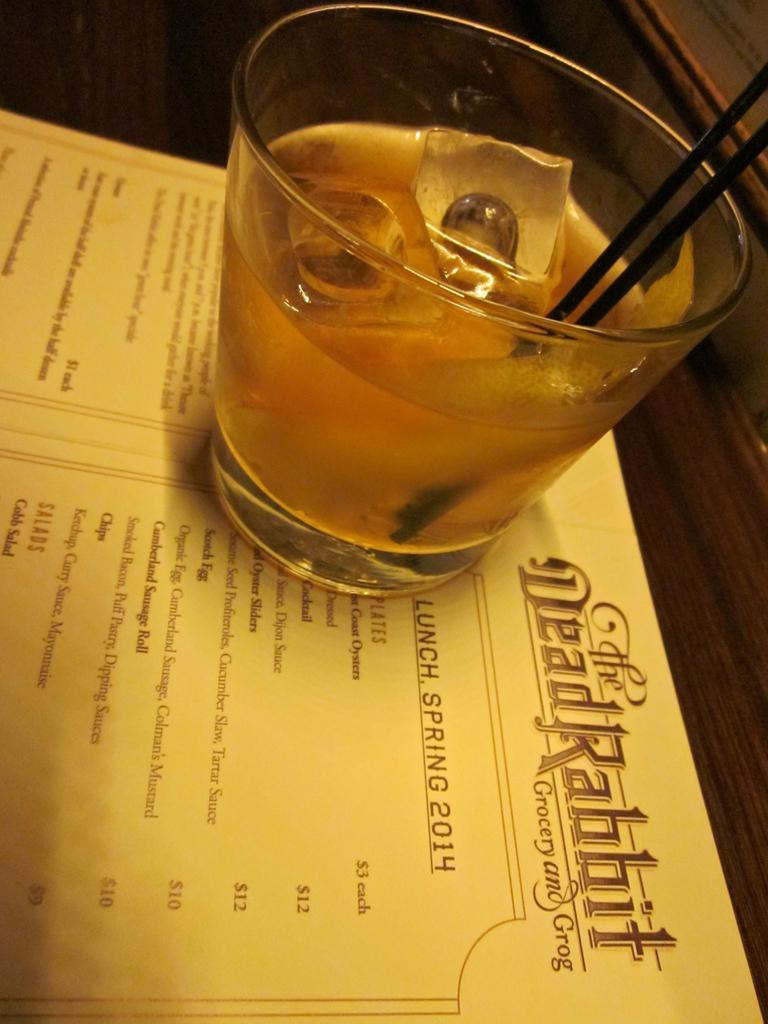<image>
Describe the image concisely. A glass sitting on top of a menu from Dead Rabbit Grocery and Grog. 